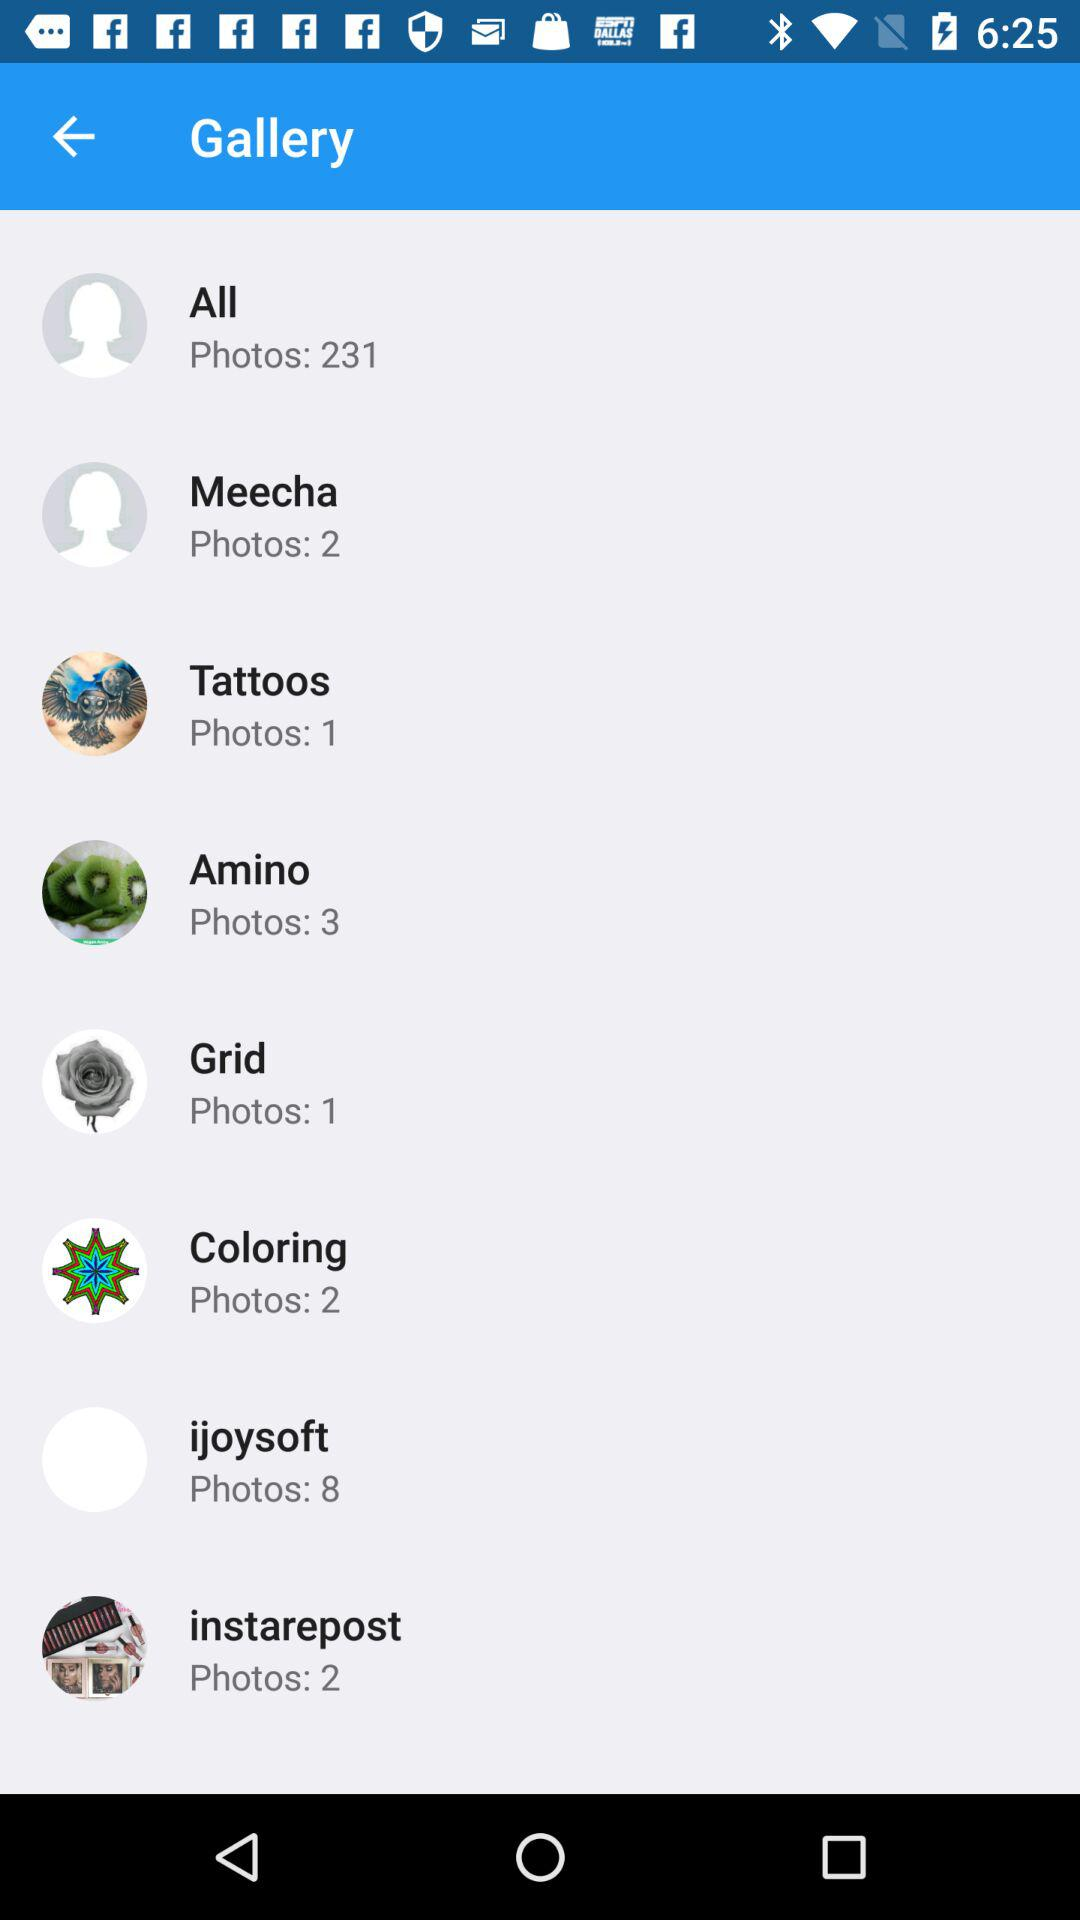What's the total number of photos in "All"? There are 231 photos. 